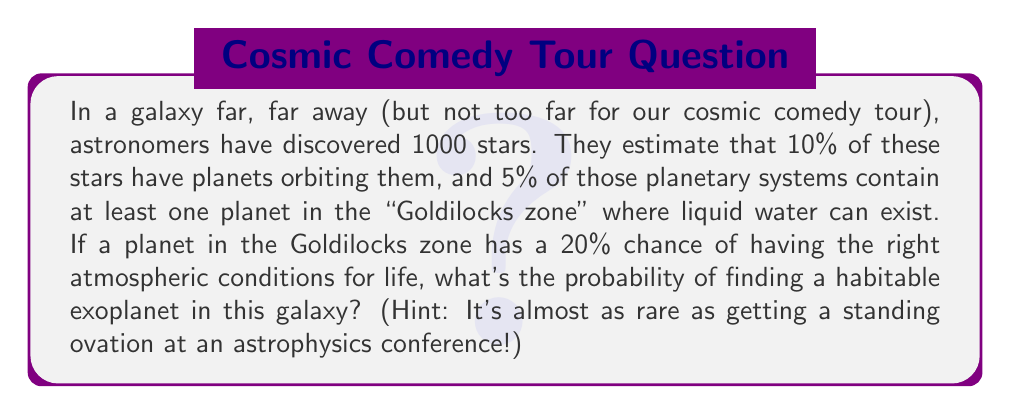Provide a solution to this math problem. Let's break this down step-by-step, like deconstructing a perfect cosmic punchline:

1) First, let's calculate the number of stars with planets:
   $1000 \times 10\% = 1000 \times 0.10 = 100$ stars with planets

2) Now, let's find how many of these planetary systems have a planet in the Goldilocks zone:
   $100 \times 5\% = 100 \times 0.05 = 5$ systems with a Goldilocks planet

3) Finally, we need to calculate the probability that one of these Goldilocks planets is actually habitable:
   $5 \times 20\% = 5 \times 0.20 = 1$ habitable planet

4) To get the probability, we divide the number of favorable outcomes by the total number of possibilities:
   $$P(\text{habitable planet}) = \frac{\text{number of habitable planets}}{\text{total number of stars}} = \frac{1}{1000} = 0.001$$

5) We can express this as a percentage:
   $0.001 \times 100\% = 0.1\%$

So, the probability is 0.001 or 0.1%, which is indeed quite rare!
Answer: 0.001 or 0.1% 